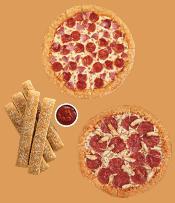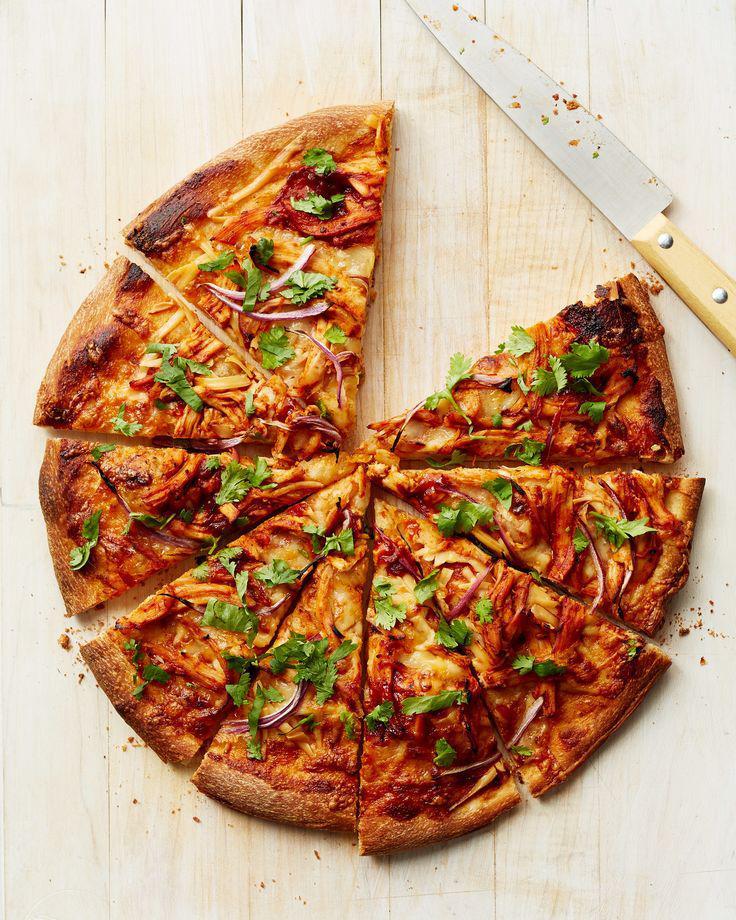The first image is the image on the left, the second image is the image on the right. Given the left and right images, does the statement "At least 2 pizzas have pepperoni on them in one of the pictures." hold true? Answer yes or no. Yes. 